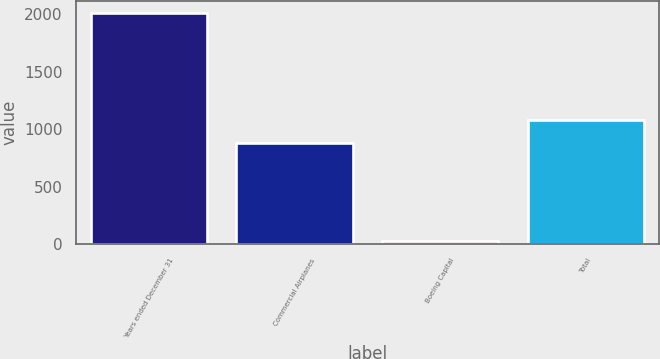Convert chart to OTSL. <chart><loc_0><loc_0><loc_500><loc_500><bar_chart><fcel>Years ended December 31<fcel>Commercial Airplanes<fcel>Boeing Capital<fcel>Total<nl><fcel>2013<fcel>879<fcel>29<fcel>1077.4<nl></chart> 